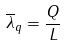<formula> <loc_0><loc_0><loc_500><loc_500>\overline { \lambda } _ { q } = \frac { Q } { L }</formula> 